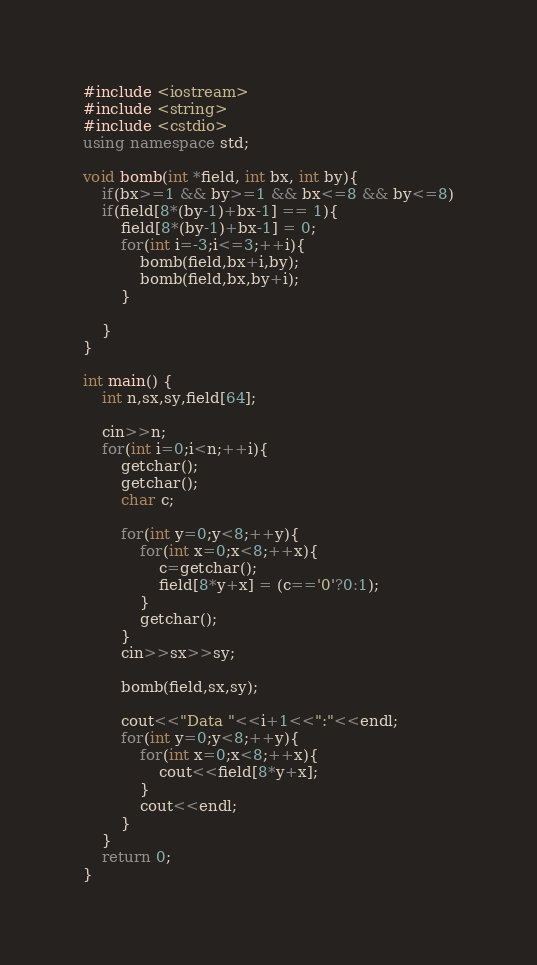Convert code to text. <code><loc_0><loc_0><loc_500><loc_500><_C++_>#include <iostream>
#include <string>
#include <cstdio>
using namespace std;

void bomb(int *field, int bx, int by){
	if(bx>=1 && by>=1 && bx<=8 && by<=8)
	if(field[8*(by-1)+bx-1] == 1){
		field[8*(by-1)+bx-1] = 0;
		for(int i=-3;i<=3;++i){
			bomb(field,bx+i,by);
			bomb(field,bx,by+i);
		}
		
	}
}

int main() {
	int n,sx,sy,field[64];
	
	cin>>n;
	for(int i=0;i<n;++i){
		getchar();
		getchar();
		char c;
		
		for(int y=0;y<8;++y){
			for(int x=0;x<8;++x){
				c=getchar();
				field[8*y+x] = (c=='0'?0:1);
			}
			getchar();
		}
		cin>>sx>>sy;
		
		bomb(field,sx,sy);
		
		cout<<"Data "<<i+1<<":"<<endl;
		for(int y=0;y<8;++y){
			for(int x=0;x<8;++x){
				cout<<field[8*y+x];
			}
			cout<<endl;
		}
	}
	return 0;
}</code> 